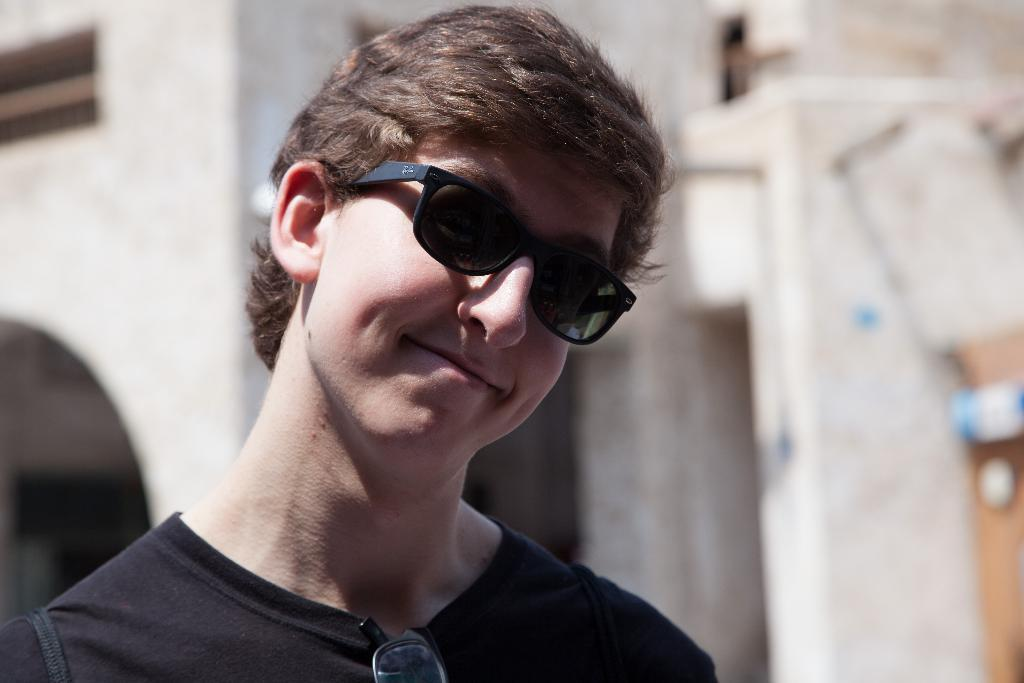What is the man in the image doing? The man is standing in the image. What accessories is the man wearing? The man is wearing sunglasses in the image. What color is the t-shirt the man is wearing? The man is wearing a black t-shirt in the image. Can you describe anything else visible in the image? There is another pair of sunglasses visible in the image. What can be seen in the background of the image? There is a building in the background of the image. What type of paint is being used by the bears in the image? There are no bears present in the image, so it is not possible to determine what type of paint they might be using. 